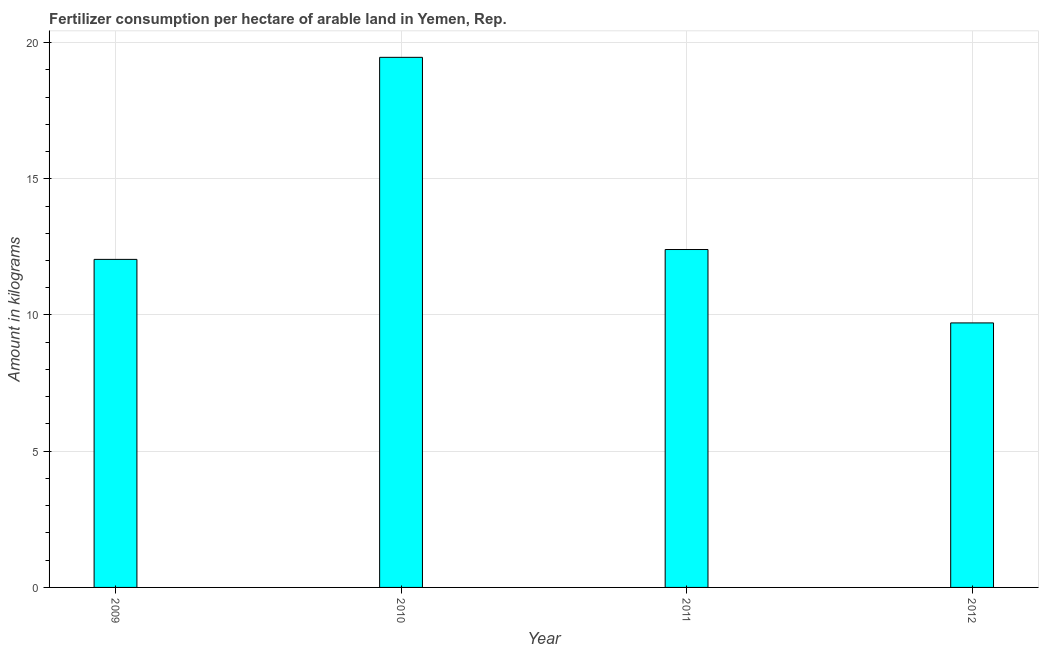What is the title of the graph?
Your answer should be compact. Fertilizer consumption per hectare of arable land in Yemen, Rep. . What is the label or title of the Y-axis?
Make the answer very short. Amount in kilograms. What is the amount of fertilizer consumption in 2012?
Ensure brevity in your answer.  9.71. Across all years, what is the maximum amount of fertilizer consumption?
Make the answer very short. 19.46. Across all years, what is the minimum amount of fertilizer consumption?
Make the answer very short. 9.71. In which year was the amount of fertilizer consumption maximum?
Offer a terse response. 2010. In which year was the amount of fertilizer consumption minimum?
Your response must be concise. 2012. What is the sum of the amount of fertilizer consumption?
Ensure brevity in your answer.  53.61. What is the difference between the amount of fertilizer consumption in 2011 and 2012?
Offer a terse response. 2.69. What is the average amount of fertilizer consumption per year?
Make the answer very short. 13.4. What is the median amount of fertilizer consumption?
Provide a succinct answer. 12.22. Do a majority of the years between 2009 and 2010 (inclusive) have amount of fertilizer consumption greater than 3 kg?
Offer a terse response. Yes. What is the ratio of the amount of fertilizer consumption in 2010 to that in 2011?
Make the answer very short. 1.57. Is the difference between the amount of fertilizer consumption in 2010 and 2011 greater than the difference between any two years?
Your answer should be compact. No. What is the difference between the highest and the second highest amount of fertilizer consumption?
Keep it short and to the point. 7.05. What is the difference between the highest and the lowest amount of fertilizer consumption?
Your response must be concise. 9.75. In how many years, is the amount of fertilizer consumption greater than the average amount of fertilizer consumption taken over all years?
Your answer should be very brief. 1. How many bars are there?
Keep it short and to the point. 4. Are all the bars in the graph horizontal?
Your response must be concise. No. What is the difference between two consecutive major ticks on the Y-axis?
Provide a short and direct response. 5. Are the values on the major ticks of Y-axis written in scientific E-notation?
Your response must be concise. No. What is the Amount in kilograms in 2009?
Keep it short and to the point. 12.04. What is the Amount in kilograms of 2010?
Keep it short and to the point. 19.46. What is the Amount in kilograms in 2011?
Offer a terse response. 12.4. What is the Amount in kilograms of 2012?
Your answer should be compact. 9.71. What is the difference between the Amount in kilograms in 2009 and 2010?
Your answer should be very brief. -7.42. What is the difference between the Amount in kilograms in 2009 and 2011?
Your answer should be compact. -0.36. What is the difference between the Amount in kilograms in 2009 and 2012?
Your answer should be very brief. 2.33. What is the difference between the Amount in kilograms in 2010 and 2011?
Give a very brief answer. 7.05. What is the difference between the Amount in kilograms in 2010 and 2012?
Your answer should be compact. 9.75. What is the difference between the Amount in kilograms in 2011 and 2012?
Your response must be concise. 2.69. What is the ratio of the Amount in kilograms in 2009 to that in 2010?
Your response must be concise. 0.62. What is the ratio of the Amount in kilograms in 2009 to that in 2011?
Give a very brief answer. 0.97. What is the ratio of the Amount in kilograms in 2009 to that in 2012?
Your response must be concise. 1.24. What is the ratio of the Amount in kilograms in 2010 to that in 2011?
Offer a terse response. 1.57. What is the ratio of the Amount in kilograms in 2010 to that in 2012?
Ensure brevity in your answer.  2. What is the ratio of the Amount in kilograms in 2011 to that in 2012?
Provide a short and direct response. 1.28. 